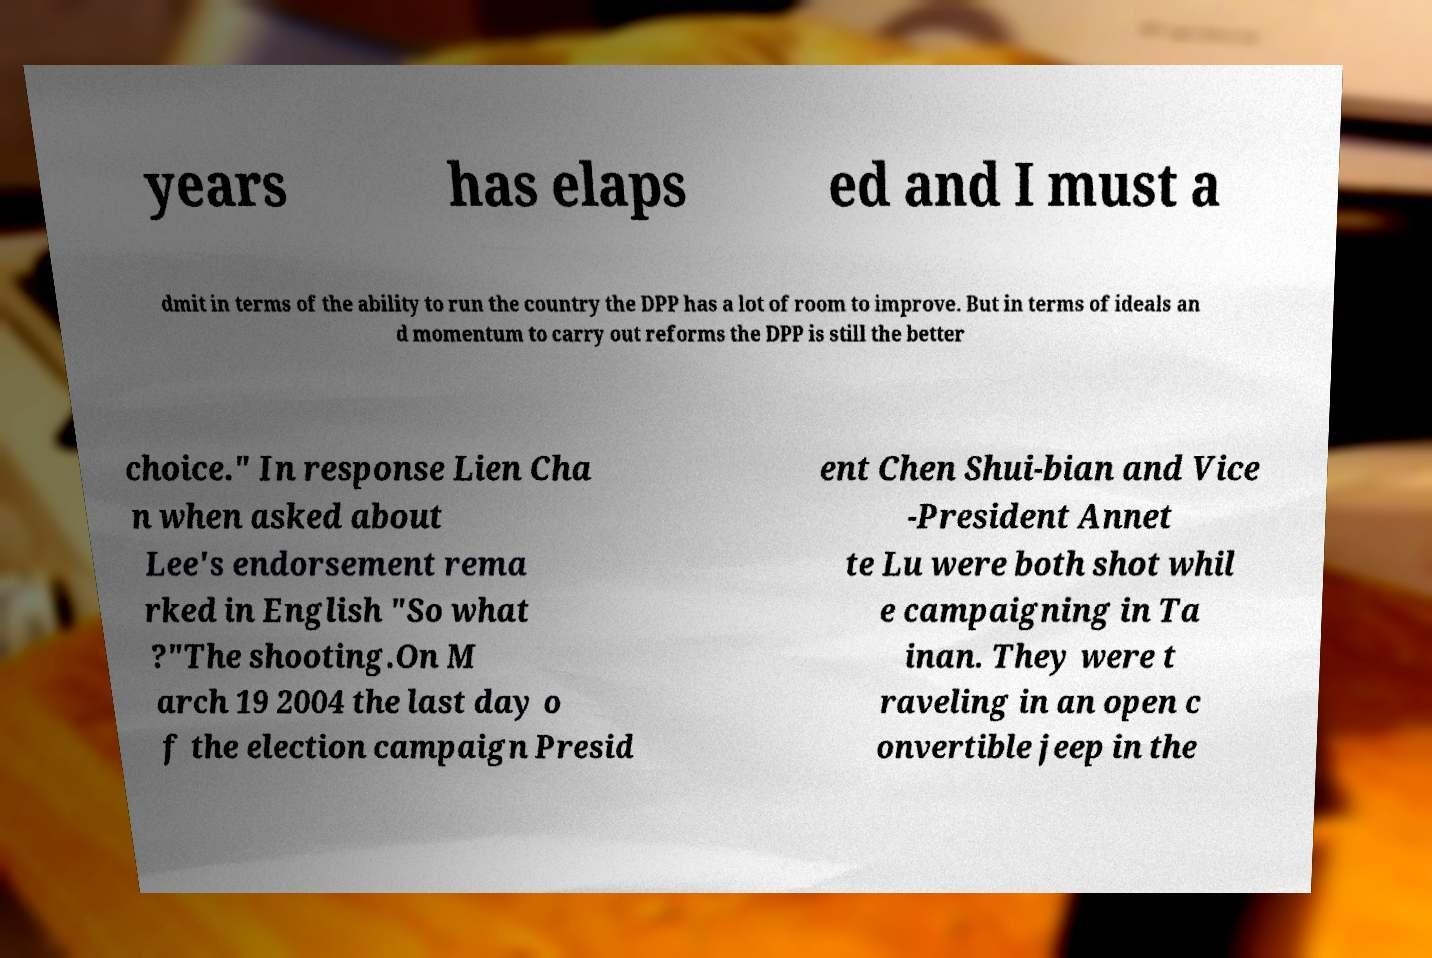Could you extract and type out the text from this image? years has elaps ed and I must a dmit in terms of the ability to run the country the DPP has a lot of room to improve. But in terms of ideals an d momentum to carry out reforms the DPP is still the better choice." In response Lien Cha n when asked about Lee's endorsement rema rked in English "So what ?"The shooting.On M arch 19 2004 the last day o f the election campaign Presid ent Chen Shui-bian and Vice -President Annet te Lu were both shot whil e campaigning in Ta inan. They were t raveling in an open c onvertible jeep in the 